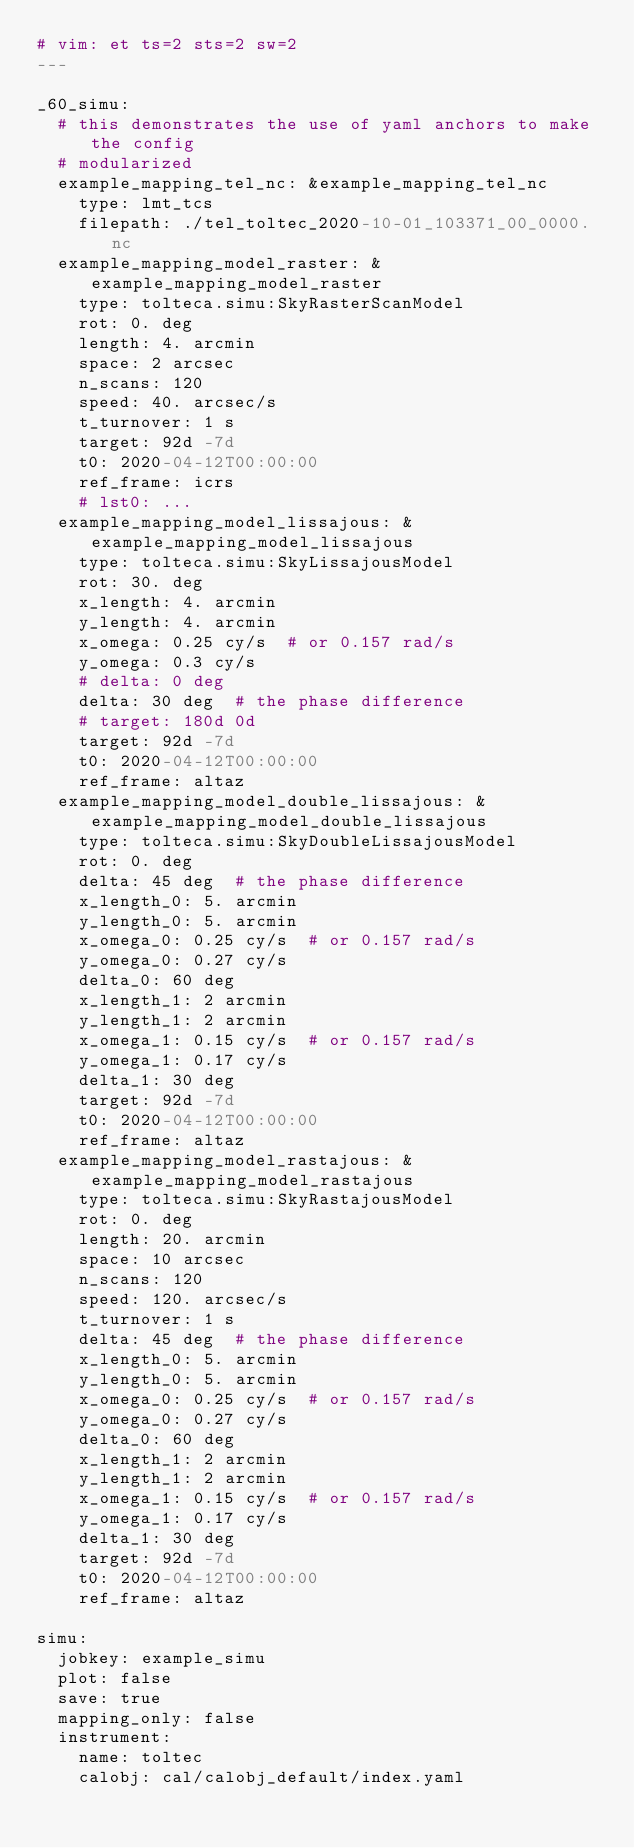Convert code to text. <code><loc_0><loc_0><loc_500><loc_500><_YAML_># vim: et ts=2 sts=2 sw=2
---

_60_simu:
  # this demonstrates the use of yaml anchors to make the config
  # modularized
  example_mapping_tel_nc: &example_mapping_tel_nc
    type: lmt_tcs
    filepath: ./tel_toltec_2020-10-01_103371_00_0000.nc
  example_mapping_model_raster: &example_mapping_model_raster
    type: tolteca.simu:SkyRasterScanModel
    rot: 0. deg
    length: 4. arcmin
    space: 2 arcsec
    n_scans: 120
    speed: 40. arcsec/s
    t_turnover: 1 s
    target: 92d -7d
    t0: 2020-04-12T00:00:00
    ref_frame: icrs
    # lst0: ...
  example_mapping_model_lissajous: &example_mapping_model_lissajous
    type: tolteca.simu:SkyLissajousModel
    rot: 30. deg
    x_length: 4. arcmin
    y_length: 4. arcmin
    x_omega: 0.25 cy/s  # or 0.157 rad/s
    y_omega: 0.3 cy/s
    # delta: 0 deg
    delta: 30 deg  # the phase difference
    # target: 180d 0d
    target: 92d -7d
    t0: 2020-04-12T00:00:00
    ref_frame: altaz
  example_mapping_model_double_lissajous: &example_mapping_model_double_lissajous
    type: tolteca.simu:SkyDoubleLissajousModel
    rot: 0. deg
    delta: 45 deg  # the phase difference
    x_length_0: 5. arcmin
    y_length_0: 5. arcmin
    x_omega_0: 0.25 cy/s  # or 0.157 rad/s
    y_omega_0: 0.27 cy/s
    delta_0: 60 deg
    x_length_1: 2 arcmin
    y_length_1: 2 arcmin
    x_omega_1: 0.15 cy/s  # or 0.157 rad/s
    y_omega_1: 0.17 cy/s
    delta_1: 30 deg
    target: 92d -7d
    t0: 2020-04-12T00:00:00
    ref_frame: altaz
  example_mapping_model_rastajous: &example_mapping_model_rastajous
    type: tolteca.simu:SkyRastajousModel
    rot: 0. deg
    length: 20. arcmin
    space: 10 arcsec
    n_scans: 120
    speed: 120. arcsec/s
    t_turnover: 1 s
    delta: 45 deg  # the phase difference
    x_length_0: 5. arcmin
    y_length_0: 5. arcmin
    x_omega_0: 0.25 cy/s  # or 0.157 rad/s
    y_omega_0: 0.27 cy/s
    delta_0: 60 deg
    x_length_1: 2 arcmin
    y_length_1: 2 arcmin
    x_omega_1: 0.15 cy/s  # or 0.157 rad/s
    y_omega_1: 0.17 cy/s
    delta_1: 30 deg
    target: 92d -7d
    t0: 2020-04-12T00:00:00
    ref_frame: altaz

simu:
  jobkey: example_simu
  plot: false
  save: true
  mapping_only: false
  instrument:
    name: toltec
    calobj: cal/calobj_default/index.yaml</code> 